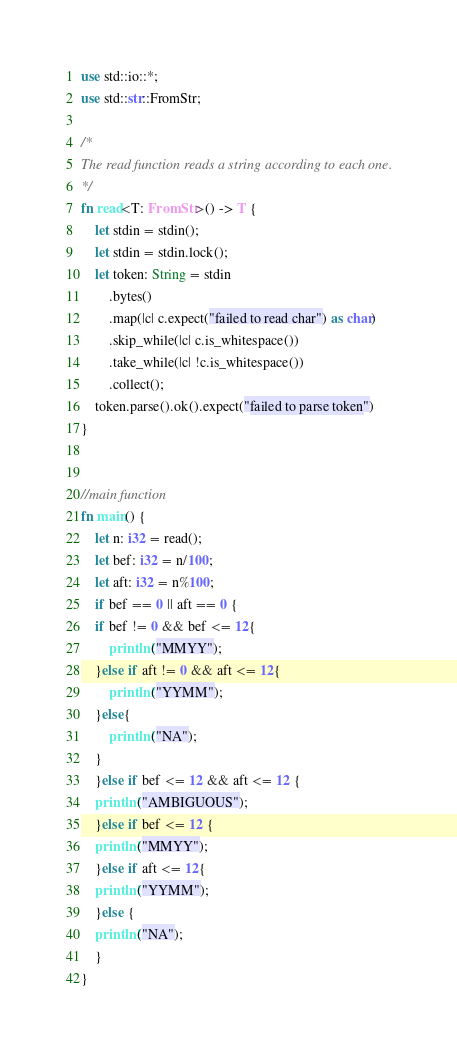<code> <loc_0><loc_0><loc_500><loc_500><_Rust_>use std::io::*;
use std::str::FromStr;
 
/* 
The read function reads a string according to each one. 
*/
fn read<T: FromStr>() -> T {
    let stdin = stdin();
    let stdin = stdin.lock();
    let token: String = stdin
        .bytes()
        .map(|c| c.expect("failed to read char") as char) 
        .skip_while(|c| c.is_whitespace())
        .take_while(|c| !c.is_whitespace())
        .collect();
    token.parse().ok().expect("failed to parse token")
}


//main function
fn main() {
    let n: i32 = read();
    let bef: i32 = n/100;
    let aft: i32 = n%100;
    if bef == 0 || aft == 0 {
	if bef != 0 && bef <= 12{
	    println!("MMYY");
	}else if aft != 0 && aft <= 12{
	    println!("YYMM");
	}else{
	    println!("NA");
	}
    }else if bef <= 12 && aft <= 12 {
	println!("AMBIGUOUS");
    }else if bef <= 12 {
	println!("MMYY");
    }else if aft <= 12{
	println!("YYMM");
    }else {
	println!("NA");
    }
}
</code> 